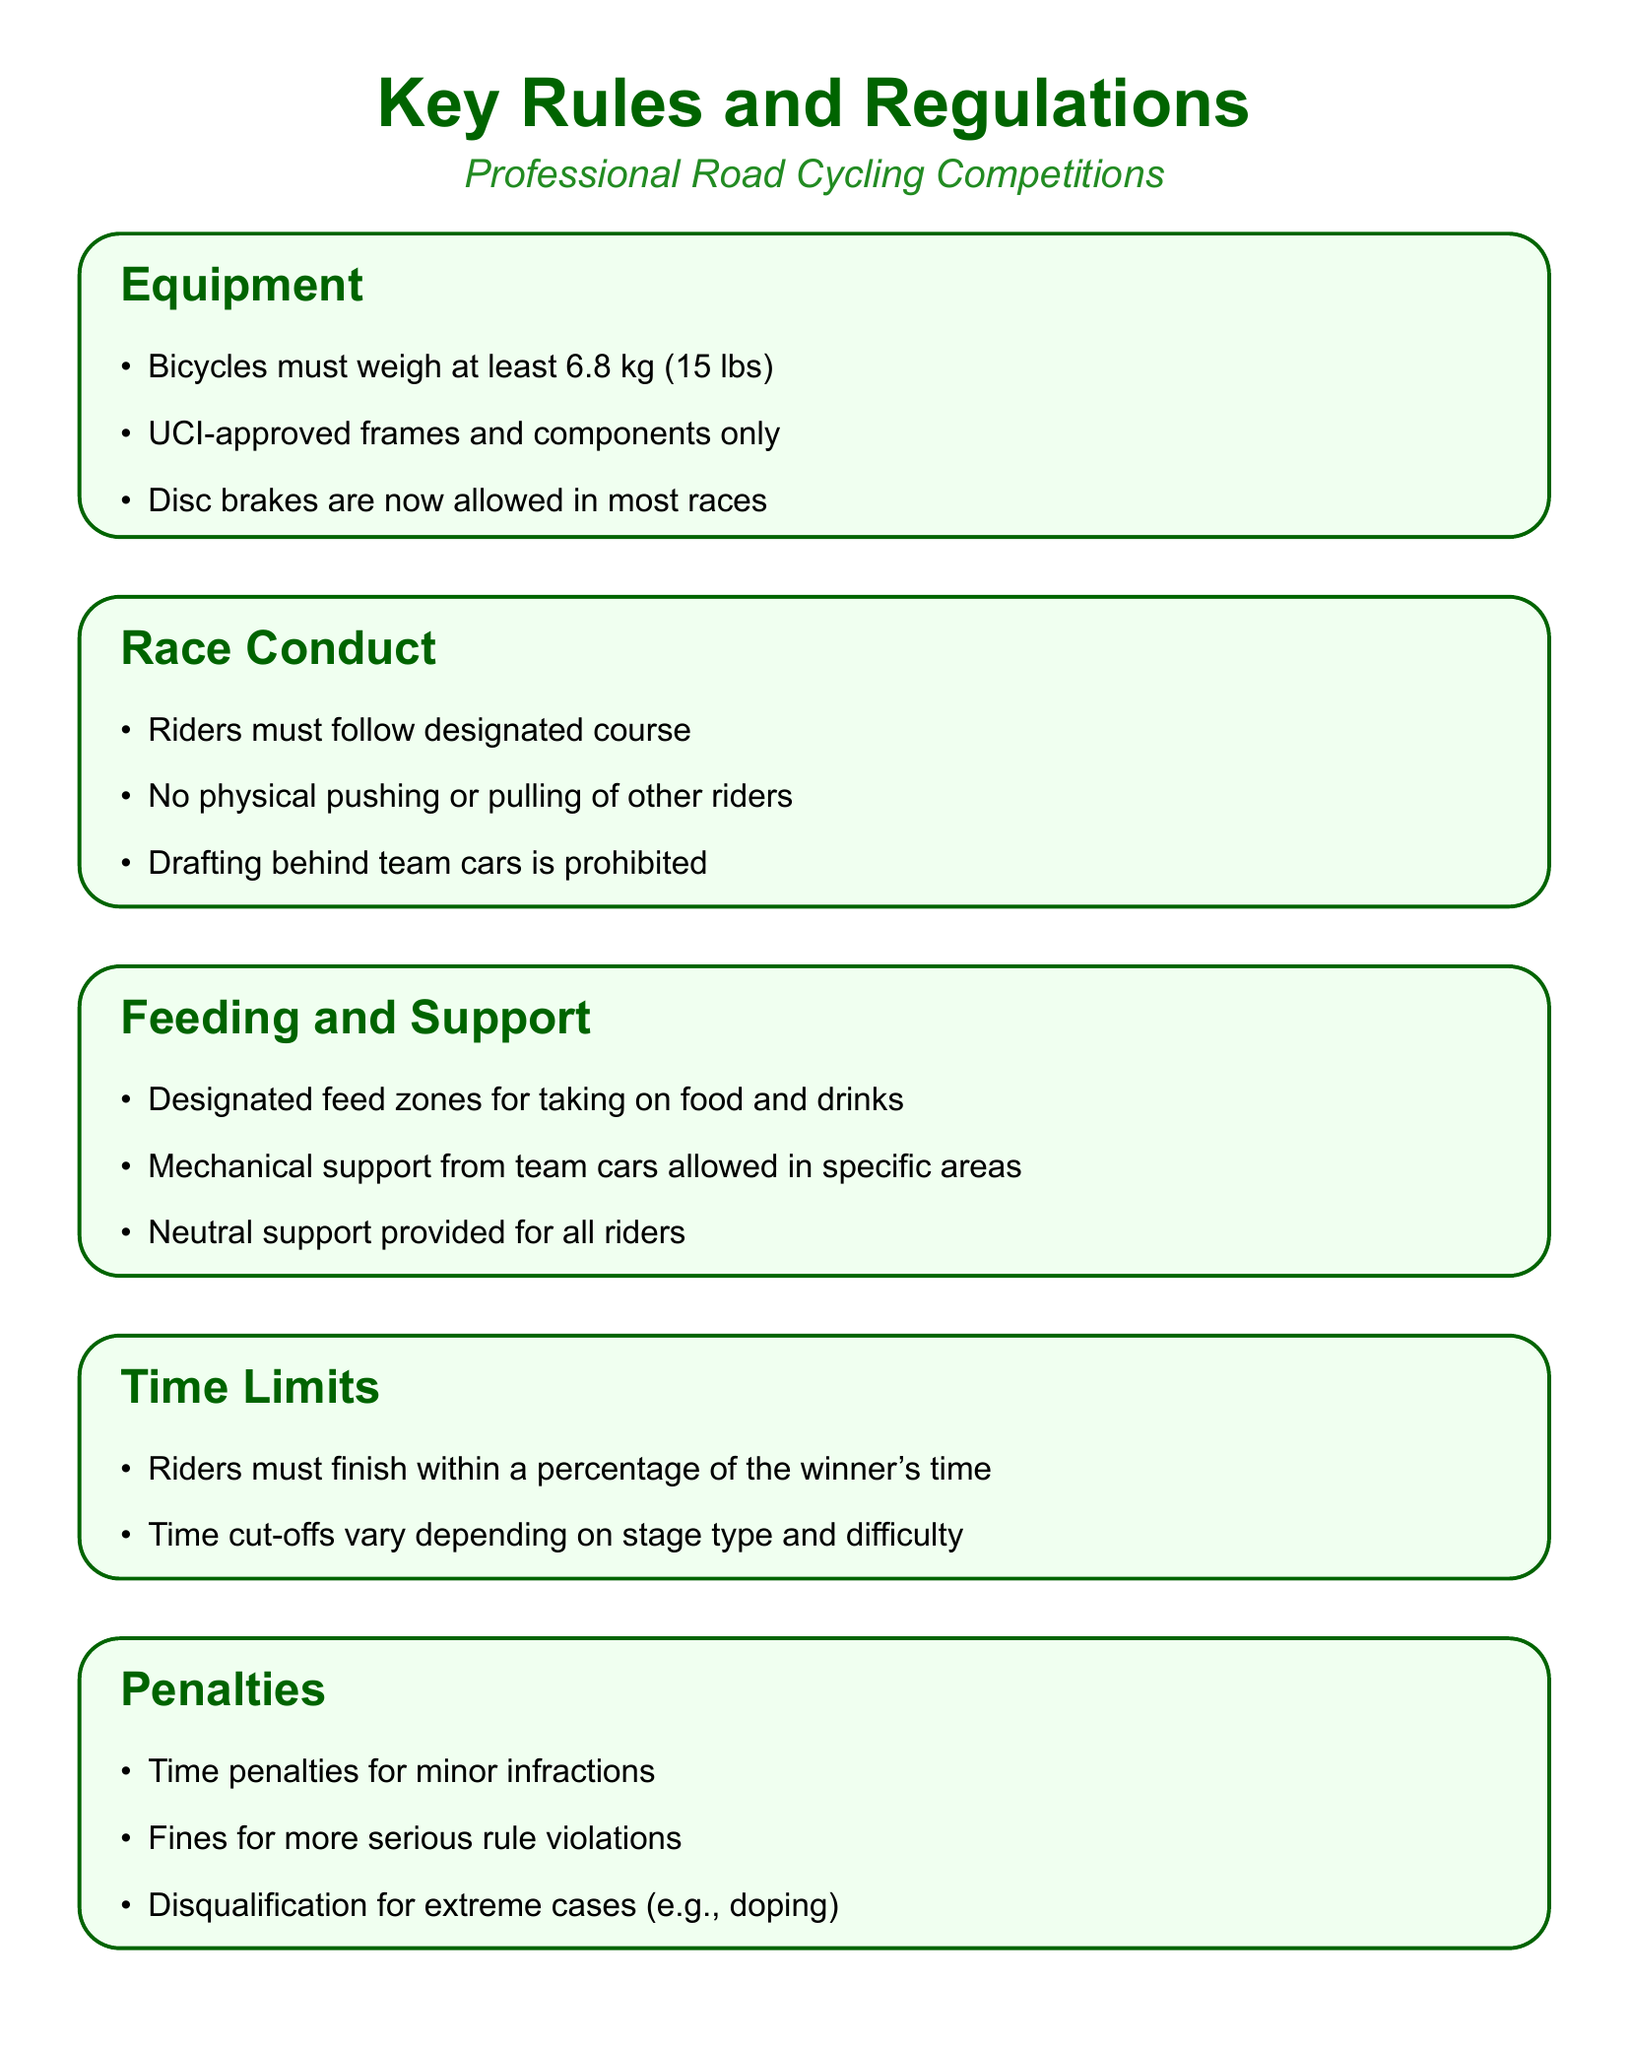What is the minimum weight for bicycles? The document states that bicycles must weigh at least 6.8 kg (15 lbs).
Answer: 6.8 kg (15 lbs) Are disc brakes allowed in most races? The document indicates that disc brakes are now allowed in most races.
Answer: Yes What is prohibited regarding drafting? According to the document, drafting behind team cars is prohibited.
Answer: Drafting behind team cars What happens if a rider doesn't finish within the time limits? The document mentions that riders must finish within a percentage of the winner's time, otherwise, they may face penalties.
Answer: Penalties What is the name of the jersey for the overall leader in the Tour de France? The document identifies the overall leader's jersey as the Yellow Jersey in the Tour de France.
Answer: Yellow Jersey What kind of support is provided for all riders? The document states that neutral support is provided for all riders.
Answer: Neutral support What can result in disqualification? The document specifies that extreme cases, such as doping, can lead to disqualification.
Answer: Doping 